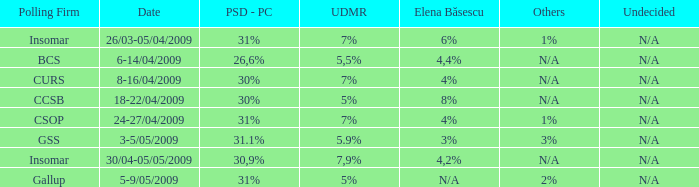What was the polling firm with others of 1%? Insomar, CSOP. 